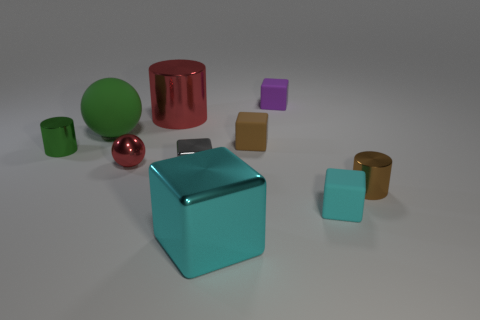Subtract 2 blocks. How many blocks are left? 3 Subtract all purple cubes. How many cubes are left? 4 Subtract all yellow blocks. Subtract all red cylinders. How many blocks are left? 5 Subtract all spheres. How many objects are left? 8 Add 4 tiny cyan rubber cylinders. How many tiny cyan rubber cylinders exist? 4 Subtract 0 gray balls. How many objects are left? 10 Subtract all big blue rubber blocks. Subtract all green matte balls. How many objects are left? 9 Add 9 gray objects. How many gray objects are left? 10 